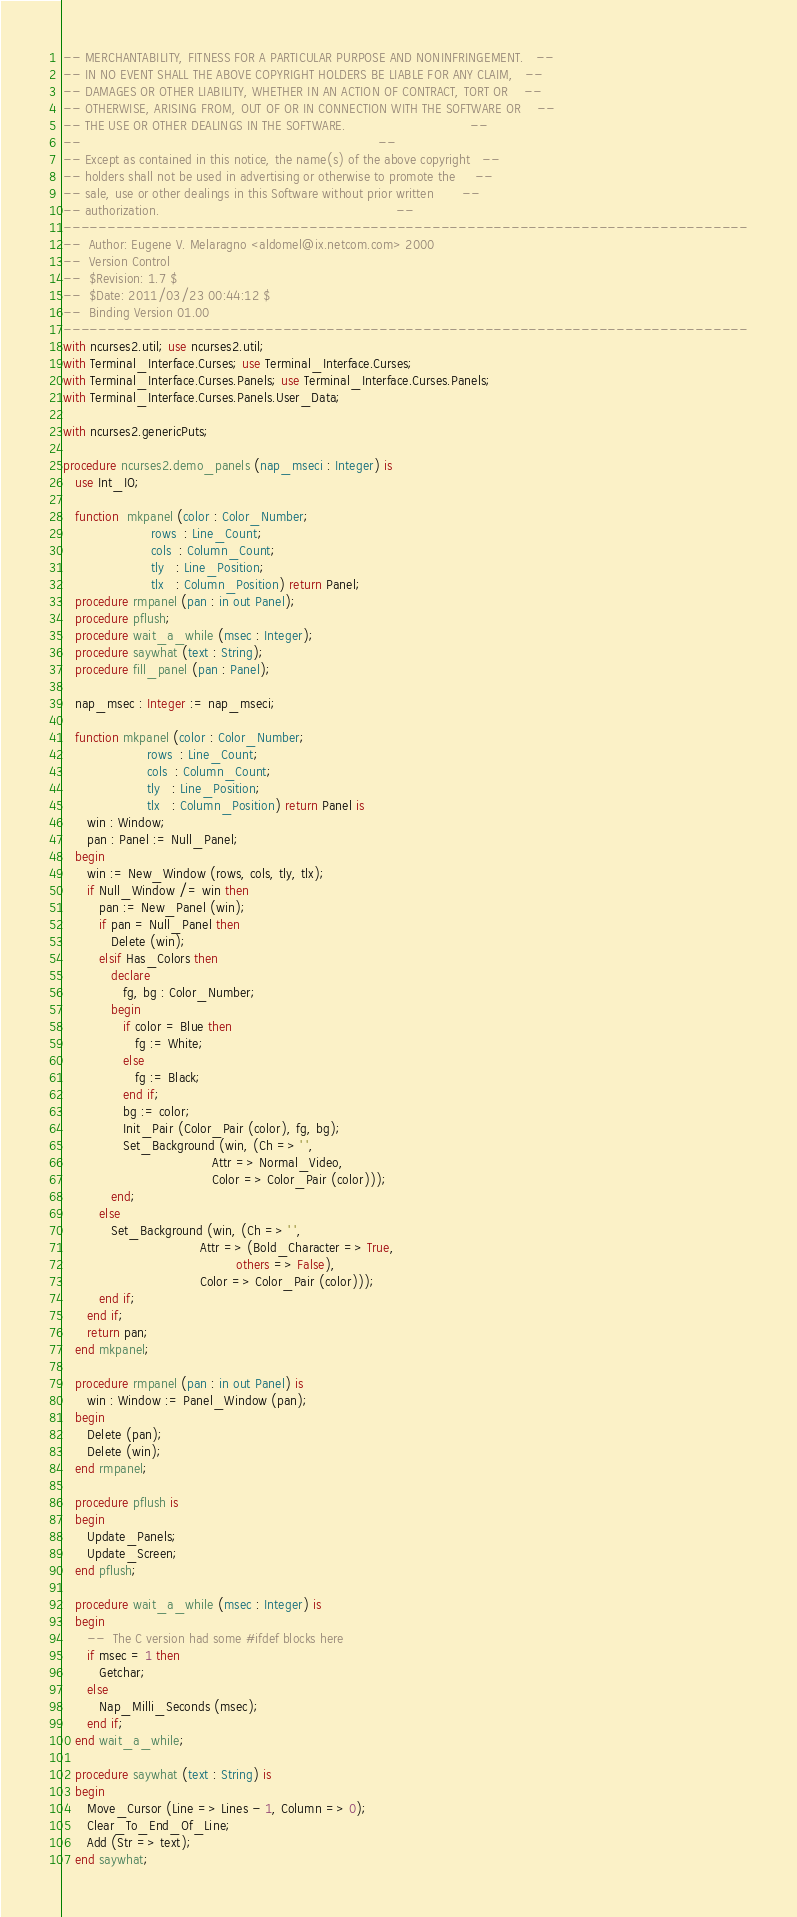<code> <loc_0><loc_0><loc_500><loc_500><_Ada_>-- MERCHANTABILITY, FITNESS FOR A PARTICULAR PURPOSE AND NONINFRINGEMENT.   --
-- IN NO EVENT SHALL THE ABOVE COPYRIGHT HOLDERS BE LIABLE FOR ANY CLAIM,   --
-- DAMAGES OR OTHER LIABILITY, WHETHER IN AN ACTION OF CONTRACT, TORT OR    --
-- OTHERWISE, ARISING FROM, OUT OF OR IN CONNECTION WITH THE SOFTWARE OR    --
-- THE USE OR OTHER DEALINGS IN THE SOFTWARE.                               --
--                                                                          --
-- Except as contained in this notice, the name(s) of the above copyright   --
-- holders shall not be used in advertising or otherwise to promote the     --
-- sale, use or other dealings in this Software without prior written       --
-- authorization.                                                           --
------------------------------------------------------------------------------
--  Author: Eugene V. Melaragno <aldomel@ix.netcom.com> 2000
--  Version Control
--  $Revision: 1.7 $
--  $Date: 2011/03/23 00:44:12 $
--  Binding Version 01.00
------------------------------------------------------------------------------
with ncurses2.util; use ncurses2.util;
with Terminal_Interface.Curses; use Terminal_Interface.Curses;
with Terminal_Interface.Curses.Panels; use Terminal_Interface.Curses.Panels;
with Terminal_Interface.Curses.Panels.User_Data;

with ncurses2.genericPuts;

procedure ncurses2.demo_panels (nap_mseci : Integer) is
   use Int_IO;

   function  mkpanel (color : Color_Number;
                      rows  : Line_Count;
                      cols  : Column_Count;
                      tly   : Line_Position;
                      tlx   : Column_Position) return Panel;
   procedure rmpanel (pan : in out Panel);
   procedure pflush;
   procedure wait_a_while (msec : Integer);
   procedure saywhat (text : String);
   procedure fill_panel (pan : Panel);

   nap_msec : Integer := nap_mseci;

   function mkpanel (color : Color_Number;
                     rows  : Line_Count;
                     cols  : Column_Count;
                     tly   : Line_Position;
                     tlx   : Column_Position) return Panel is
      win : Window;
      pan : Panel := Null_Panel;
   begin
      win := New_Window (rows, cols, tly, tlx);
      if Null_Window /= win then
         pan := New_Panel (win);
         if pan = Null_Panel then
            Delete (win);
         elsif Has_Colors then
            declare
               fg, bg : Color_Number;
            begin
               if color = Blue then
                  fg := White;
               else
                  fg := Black;
               end if;
               bg := color;
               Init_Pair (Color_Pair (color), fg, bg);
               Set_Background (win, (Ch => ' ',
                                     Attr => Normal_Video,
                                     Color => Color_Pair (color)));
            end;
         else
            Set_Background (win, (Ch => ' ',
                                  Attr => (Bold_Character => True,
                                           others => False),
                                  Color => Color_Pair (color)));
         end if;
      end if;
      return pan;
   end mkpanel;

   procedure rmpanel (pan : in out Panel) is
      win : Window := Panel_Window (pan);
   begin
      Delete (pan);
      Delete (win);
   end rmpanel;

   procedure pflush is
   begin
      Update_Panels;
      Update_Screen;
   end pflush;

   procedure wait_a_while (msec : Integer) is
   begin
      --  The C version had some #ifdef blocks here
      if msec = 1 then
         Getchar;
      else
         Nap_Milli_Seconds (msec);
      end if;
   end wait_a_while;

   procedure saywhat (text : String) is
   begin
      Move_Cursor (Line => Lines - 1, Column => 0);
      Clear_To_End_Of_Line;
      Add (Str => text);
   end saywhat;
</code> 